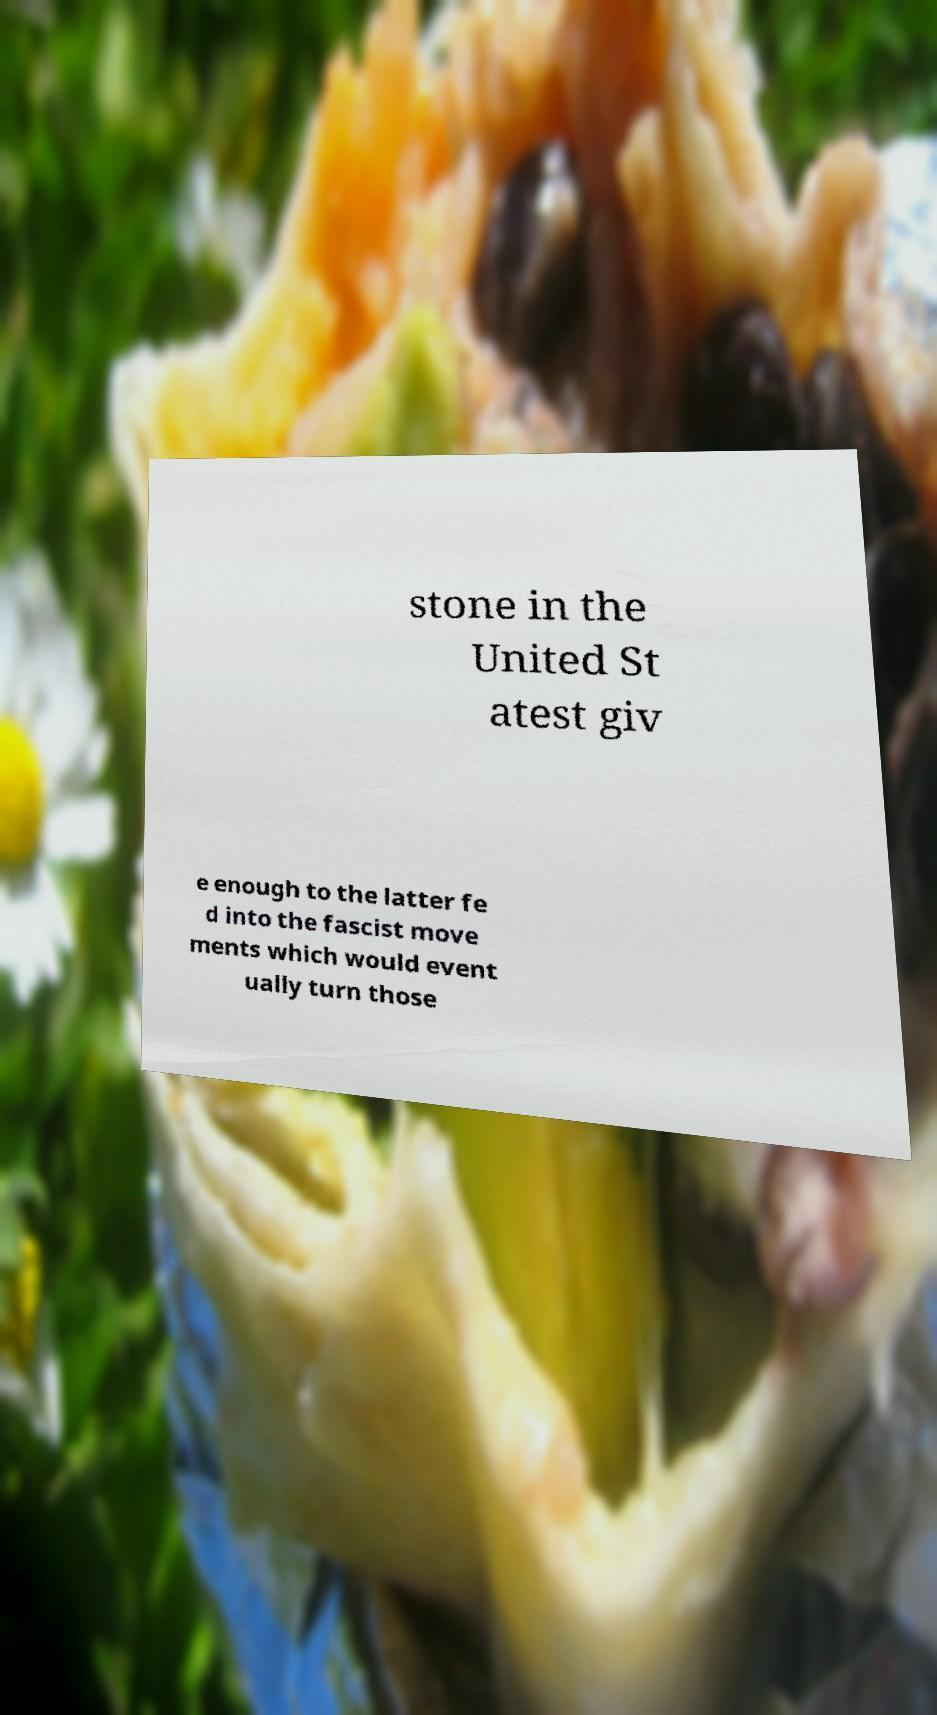Could you extract and type out the text from this image? stone in the United St atest giv e enough to the latter fe d into the fascist move ments which would event ually turn those 